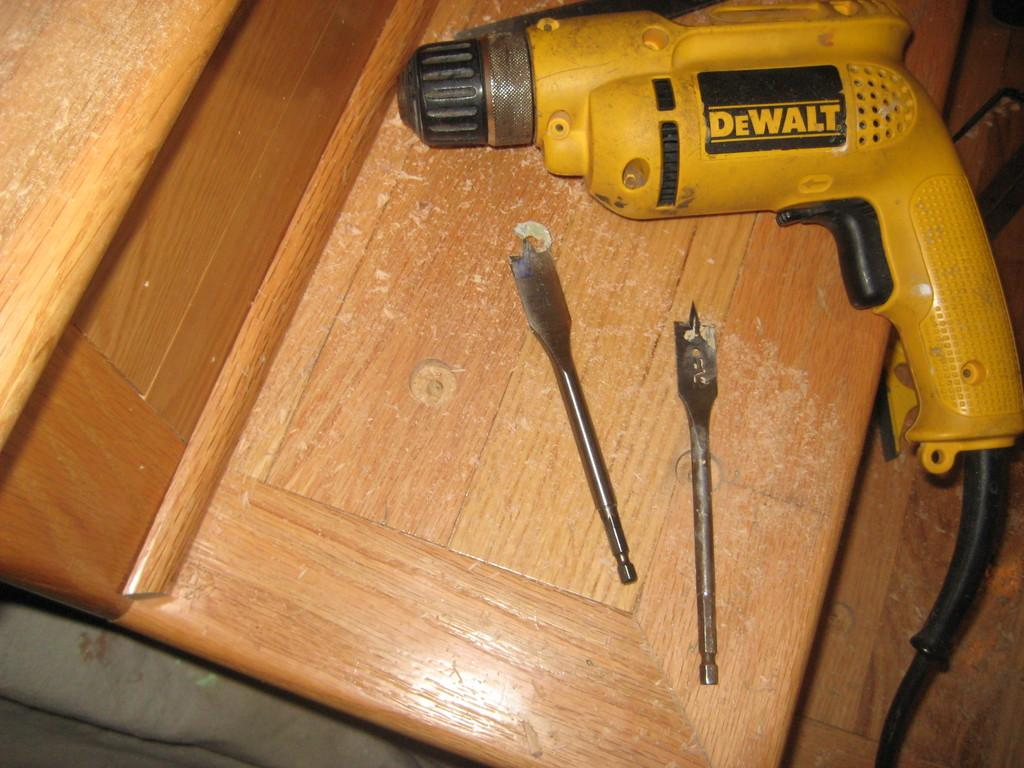What type of furniture is in the image? There is a table in the image. What is placed on the table? A drilling machine is present on the table. Can you describe the drilling machine? The drilling machine has wires and blades. What part of the room can be seen at the bottom of the image? The floor is visible at the bottom of the image. What type of support can be seen in the image? There is no specific support structure mentioned in the image; it features a table with a drilling machine on it. What type of food can be seen being produced in the image? There is no food production activity depicted in the image. 